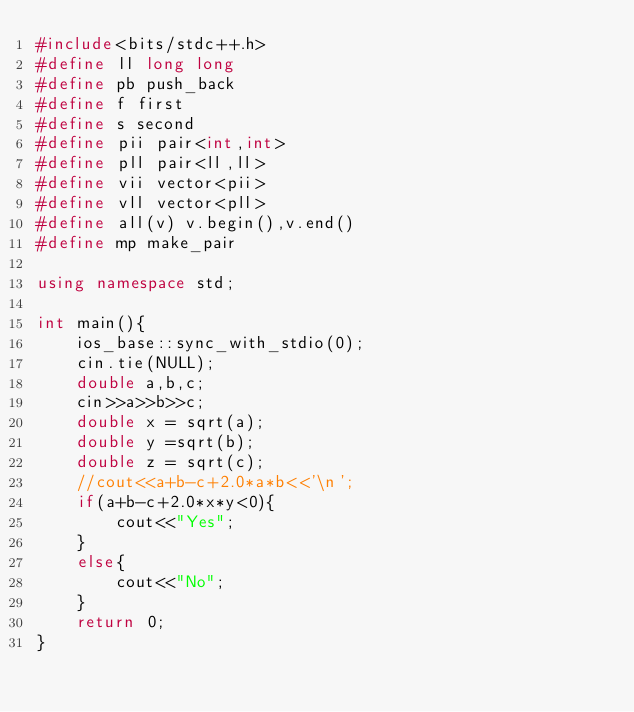Convert code to text. <code><loc_0><loc_0><loc_500><loc_500><_C++_>#include<bits/stdc++.h>
#define ll long long
#define pb push_back
#define f first
#define s second
#define pii pair<int,int>
#define pll pair<ll,ll>
#define vii vector<pii>
#define vll vector<pll>
#define all(v) v.begin(),v.end()
#define mp make_pair

using namespace std;

int main(){
	ios_base::sync_with_stdio(0);
	cin.tie(NULL);
	double a,b,c;
	cin>>a>>b>>c;
	double x = sqrt(a);
	double y =sqrt(b);
	double z = sqrt(c);
	//cout<<a+b-c+2.0*a*b<<'\n';
	if(a+b-c+2.0*x*y<0){
        cout<<"Yes";
	}
	else{
        cout<<"No";
	}
	return 0;
}
</code> 